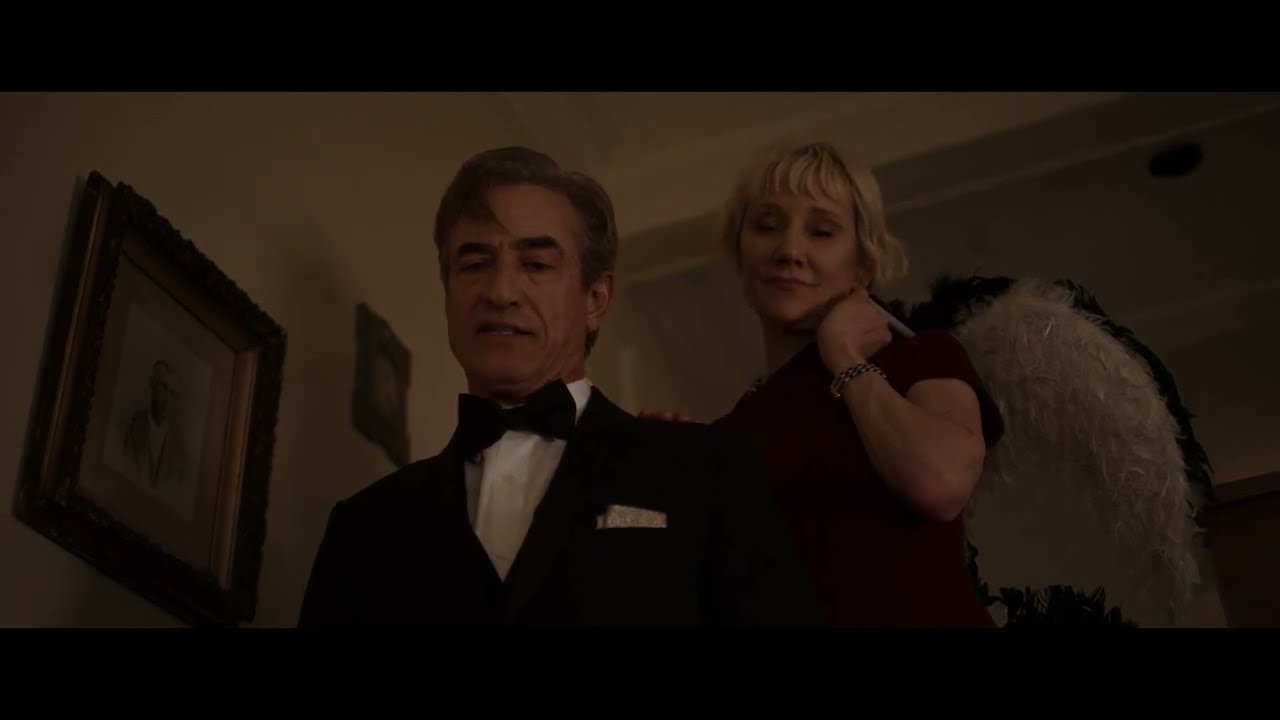Can you elaborate on the elements of the picture provided? In this evocative image, two individuals are the focal points. The man in the foreground, dressed impeccably in a black tuxedo, stands composed, exuding an air of sophistication. The dim lighting creates subtle highlights on his face, enhancing the depth of his features. Behind him, the wall is adorned with a framed picture, hinting at a taste for art and history. The woman behind him, identifiable by her blonde hair, wears a vibrant red dress paired with a white feather boa, adding a dramatic flair to the scene. Her confident demeanor and engaging smile suggest a warm interaction between her and the man. The image captures a moment brimming with elegance and intrigue, inviting viewers to ponder the story behind these characters. 